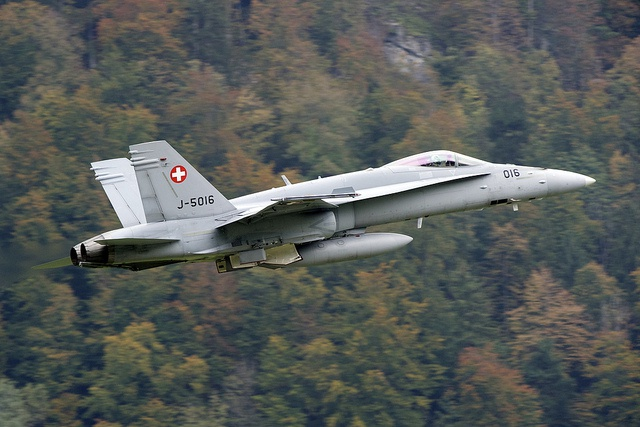Describe the objects in this image and their specific colors. I can see a airplane in darkblue, lightgray, darkgray, black, and gray tones in this image. 